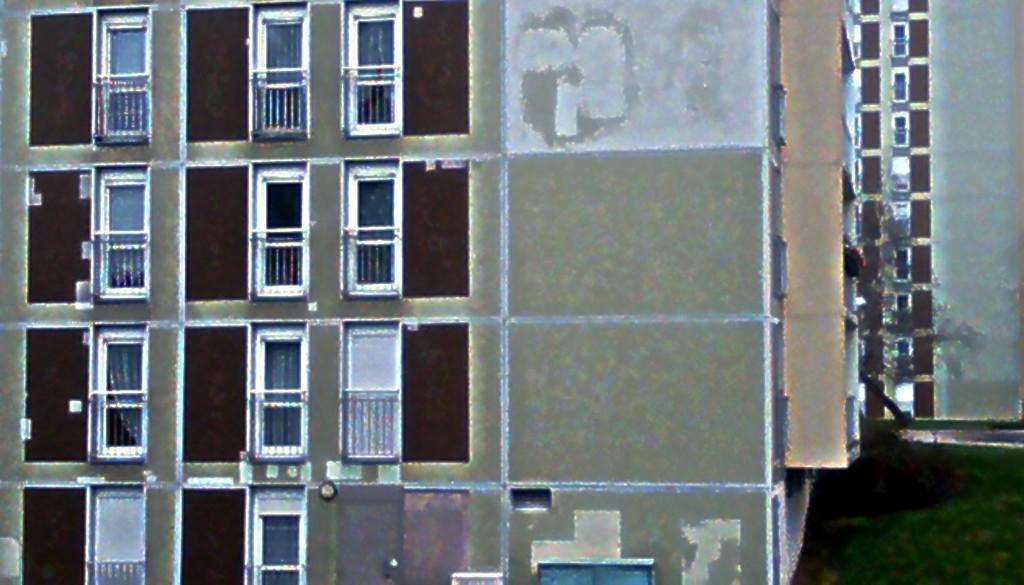Could you give a brief overview of what you see in this image? In this picture we can see the building. On the building we can see the windows, fencing and door. At the bottom there was a steel box near to the wall. At the bottom right corner we can see green grass. 